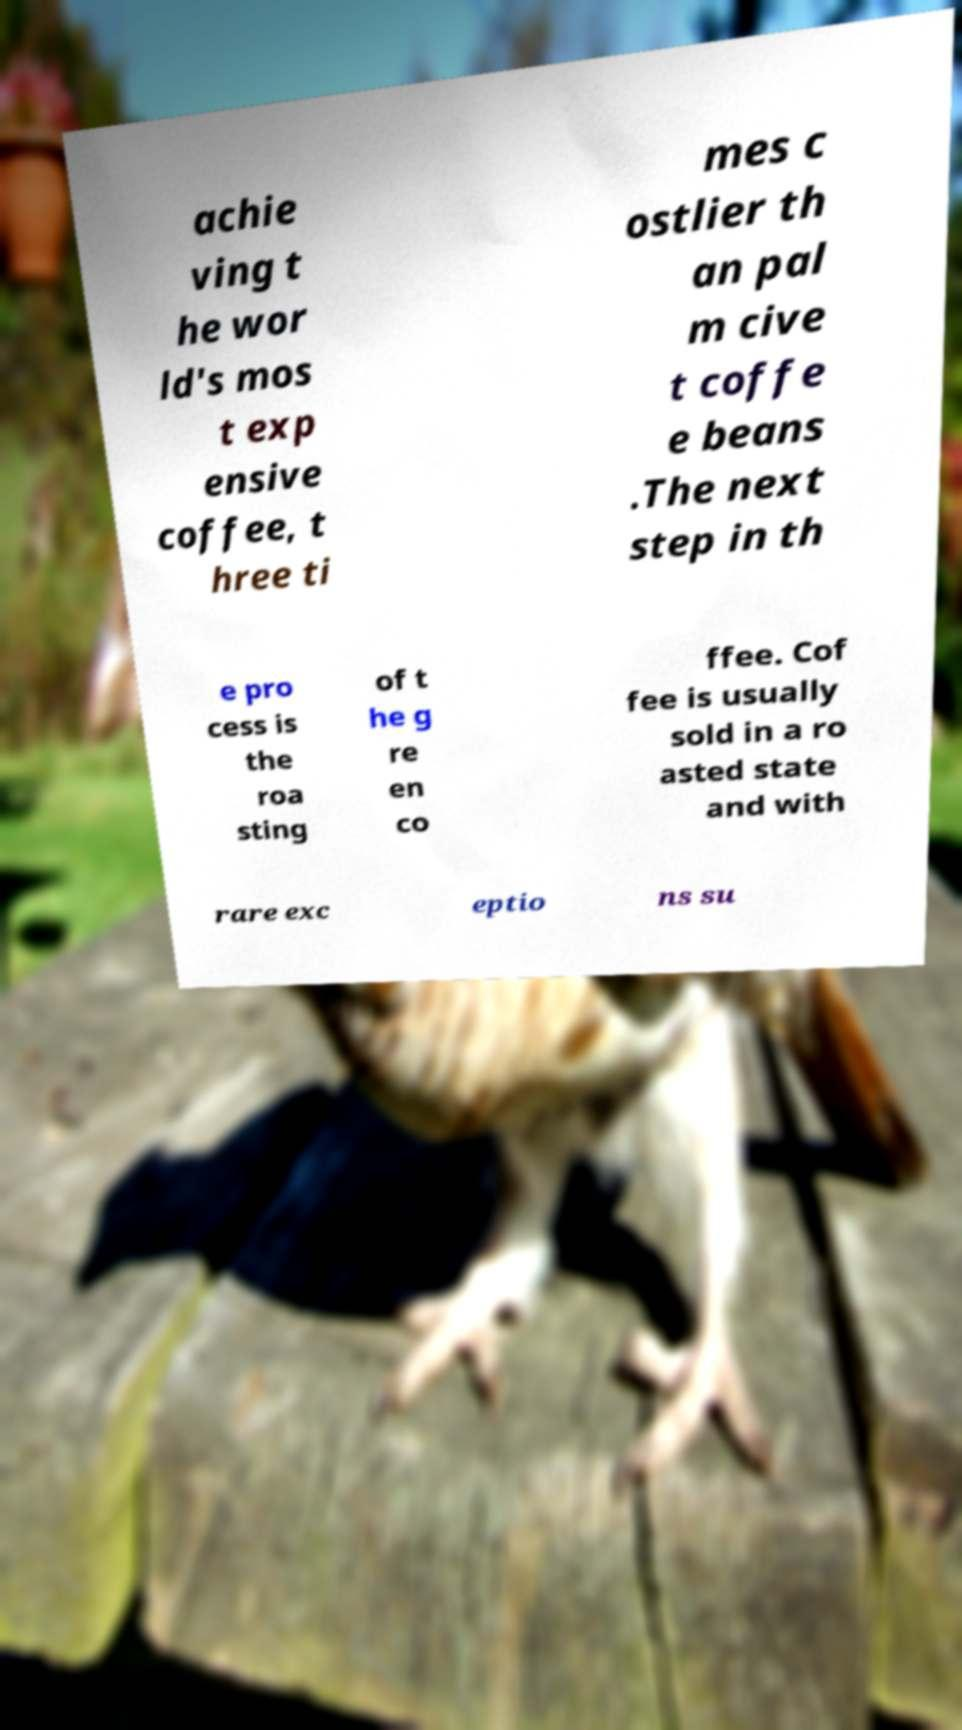Can you read and provide the text displayed in the image?This photo seems to have some interesting text. Can you extract and type it out for me? achie ving t he wor ld's mos t exp ensive coffee, t hree ti mes c ostlier th an pal m cive t coffe e beans .The next step in th e pro cess is the roa sting of t he g re en co ffee. Cof fee is usually sold in a ro asted state and with rare exc eptio ns su 